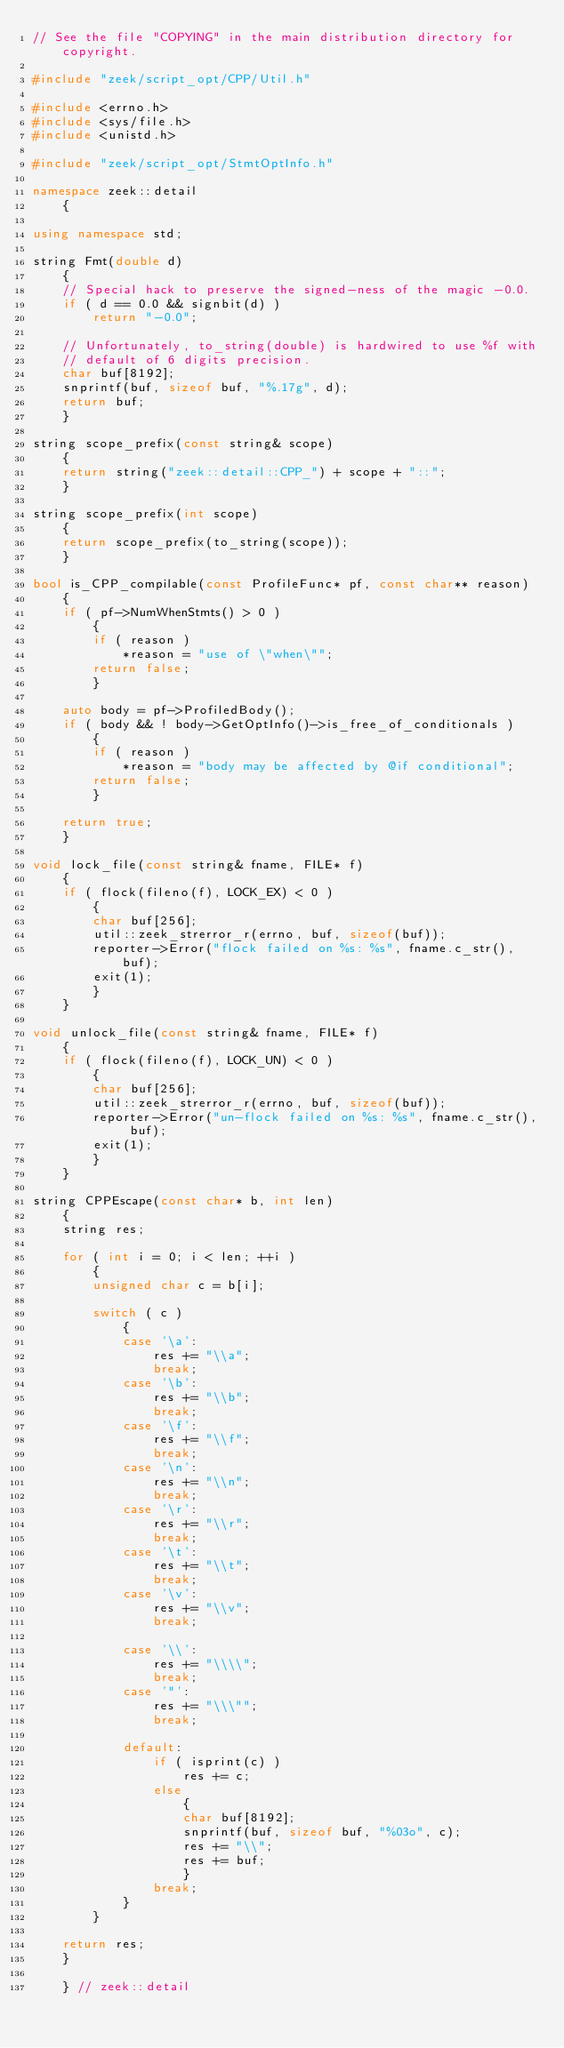Convert code to text. <code><loc_0><loc_0><loc_500><loc_500><_C++_>// See the file "COPYING" in the main distribution directory for copyright.

#include "zeek/script_opt/CPP/Util.h"

#include <errno.h>
#include <sys/file.h>
#include <unistd.h>

#include "zeek/script_opt/StmtOptInfo.h"

namespace zeek::detail
	{

using namespace std;

string Fmt(double d)
	{
	// Special hack to preserve the signed-ness of the magic -0.0.
	if ( d == 0.0 && signbit(d) )
		return "-0.0";

	// Unfortunately, to_string(double) is hardwired to use %f with
	// default of 6 digits precision.
	char buf[8192];
	snprintf(buf, sizeof buf, "%.17g", d);
	return buf;
	}

string scope_prefix(const string& scope)
	{
	return string("zeek::detail::CPP_") + scope + "::";
	}

string scope_prefix(int scope)
	{
	return scope_prefix(to_string(scope));
	}

bool is_CPP_compilable(const ProfileFunc* pf, const char** reason)
	{
	if ( pf->NumWhenStmts() > 0 )
		{
		if ( reason )
			*reason = "use of \"when\"";
		return false;
		}

	auto body = pf->ProfiledBody();
	if ( body && ! body->GetOptInfo()->is_free_of_conditionals )
		{
		if ( reason )
			*reason = "body may be affected by @if conditional";
		return false;
		}

	return true;
	}

void lock_file(const string& fname, FILE* f)
	{
	if ( flock(fileno(f), LOCK_EX) < 0 )
		{
		char buf[256];
		util::zeek_strerror_r(errno, buf, sizeof(buf));
		reporter->Error("flock failed on %s: %s", fname.c_str(), buf);
		exit(1);
		}
	}

void unlock_file(const string& fname, FILE* f)
	{
	if ( flock(fileno(f), LOCK_UN) < 0 )
		{
		char buf[256];
		util::zeek_strerror_r(errno, buf, sizeof(buf));
		reporter->Error("un-flock failed on %s: %s", fname.c_str(), buf);
		exit(1);
		}
	}

string CPPEscape(const char* b, int len)
	{
	string res;

	for ( int i = 0; i < len; ++i )
		{
		unsigned char c = b[i];

		switch ( c )
			{
			case '\a':
				res += "\\a";
				break;
			case '\b':
				res += "\\b";
				break;
			case '\f':
				res += "\\f";
				break;
			case '\n':
				res += "\\n";
				break;
			case '\r':
				res += "\\r";
				break;
			case '\t':
				res += "\\t";
				break;
			case '\v':
				res += "\\v";
				break;

			case '\\':
				res += "\\\\";
				break;
			case '"':
				res += "\\\"";
				break;

			default:
				if ( isprint(c) )
					res += c;
				else
					{
					char buf[8192];
					snprintf(buf, sizeof buf, "%03o", c);
					res += "\\";
					res += buf;
					}
				break;
			}
		}

	return res;
	}

	} // zeek::detail
</code> 